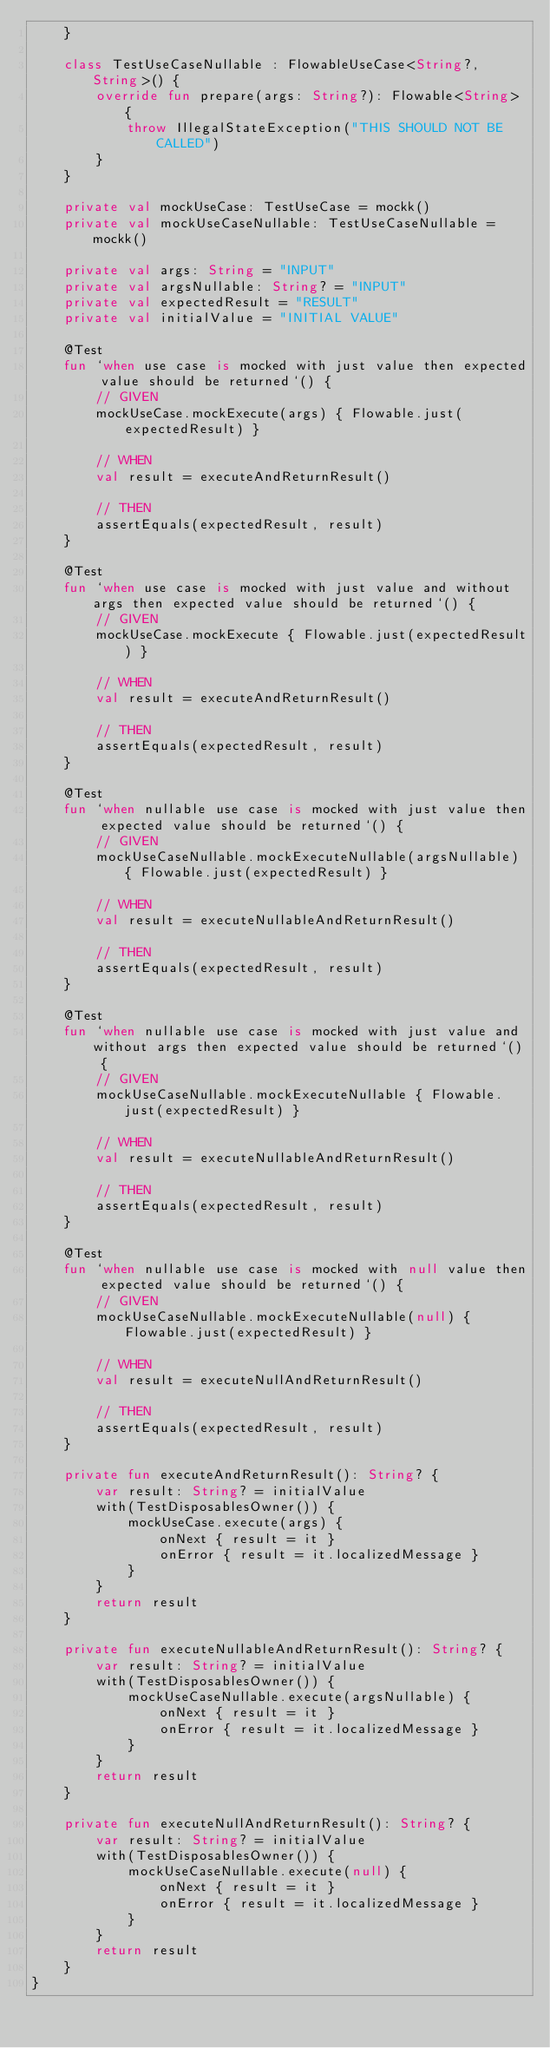Convert code to text. <code><loc_0><loc_0><loc_500><loc_500><_Kotlin_>    }

    class TestUseCaseNullable : FlowableUseCase<String?, String>() {
        override fun prepare(args: String?): Flowable<String> {
            throw IllegalStateException("THIS SHOULD NOT BE CALLED")
        }
    }

    private val mockUseCase: TestUseCase = mockk()
    private val mockUseCaseNullable: TestUseCaseNullable = mockk()

    private val args: String = "INPUT"
    private val argsNullable: String? = "INPUT"
    private val expectedResult = "RESULT"
    private val initialValue = "INITIAL VALUE"

    @Test
    fun `when use case is mocked with just value then expected value should be returned`() {
        // GIVEN
        mockUseCase.mockExecute(args) { Flowable.just(expectedResult) }

        // WHEN
        val result = executeAndReturnResult()

        // THEN
        assertEquals(expectedResult, result)
    }

    @Test
    fun `when use case is mocked with just value and without args then expected value should be returned`() {
        // GIVEN
        mockUseCase.mockExecute { Flowable.just(expectedResult) }

        // WHEN
        val result = executeAndReturnResult()

        // THEN
        assertEquals(expectedResult, result)
    }

    @Test
    fun `when nullable use case is mocked with just value then expected value should be returned`() {
        // GIVEN
        mockUseCaseNullable.mockExecuteNullable(argsNullable) { Flowable.just(expectedResult) }

        // WHEN
        val result = executeNullableAndReturnResult()

        // THEN
        assertEquals(expectedResult, result)
    }

    @Test
    fun `when nullable use case is mocked with just value and without args then expected value should be returned`() {
        // GIVEN
        mockUseCaseNullable.mockExecuteNullable { Flowable.just(expectedResult) }

        // WHEN
        val result = executeNullableAndReturnResult()

        // THEN
        assertEquals(expectedResult, result)
    }

    @Test
    fun `when nullable use case is mocked with null value then expected value should be returned`() {
        // GIVEN
        mockUseCaseNullable.mockExecuteNullable(null) { Flowable.just(expectedResult) }

        // WHEN
        val result = executeNullAndReturnResult()

        // THEN
        assertEquals(expectedResult, result)
    }

    private fun executeAndReturnResult(): String? {
        var result: String? = initialValue
        with(TestDisposablesOwner()) {
            mockUseCase.execute(args) {
                onNext { result = it }
                onError { result = it.localizedMessage }
            }
        }
        return result
    }

    private fun executeNullableAndReturnResult(): String? {
        var result: String? = initialValue
        with(TestDisposablesOwner()) {
            mockUseCaseNullable.execute(argsNullable) {
                onNext { result = it }
                onError { result = it.localizedMessage }
            }
        }
        return result
    }

    private fun executeNullAndReturnResult(): String? {
        var result: String? = initialValue
        with(TestDisposablesOwner()) {
            mockUseCaseNullable.execute(null) {
                onNext { result = it }
                onError { result = it.localizedMessage }
            }
        }
        return result
    }
}
</code> 